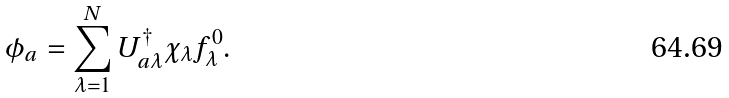Convert formula to latex. <formula><loc_0><loc_0><loc_500><loc_500>\phi _ { a } = \sum _ { \lambda = 1 } ^ { N } U _ { a \lambda } ^ { \dag } \chi _ { \lambda } f _ { \lambda } ^ { 0 } .</formula> 